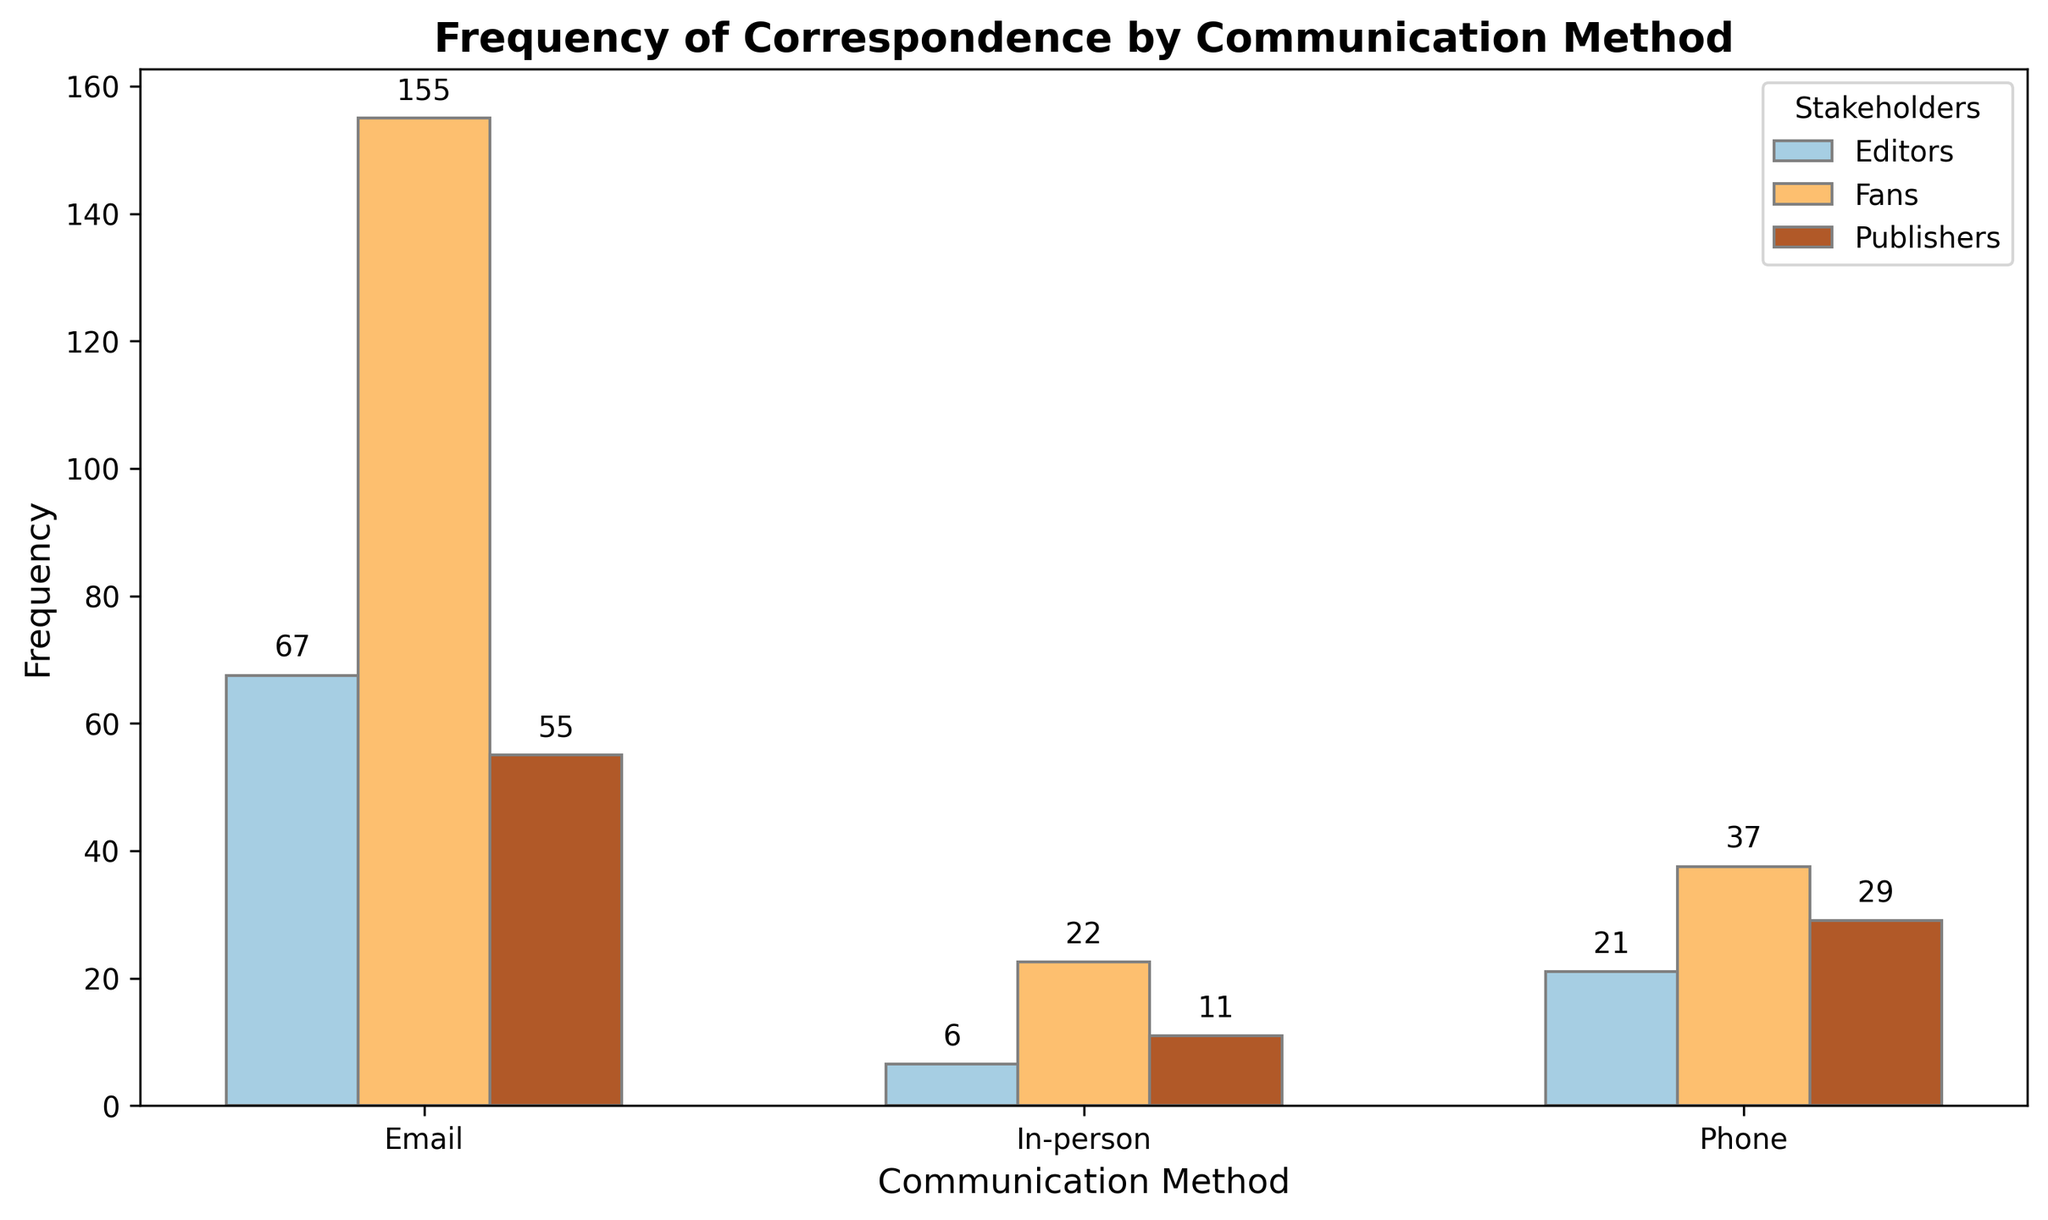What's the most common communication method with Fans? The highest bar for Fans corresponds to the "Email" method, which is taller than the bars for "Phone" and "In-person". This indicates that Fans communicate most frequently via Email.
Answer: Email How much more frequent is Email communication than Phone communication for Editors? For Editors, the frequency of Email communication is (70 + 65) / 2 = 67.5 and for Phone communication is (20 + 22) / 2 = 21. The difference is 67.5 - 21 = 46.5.
Answer: 46.5 Which stakeholder has the lowest frequency of In-person communication? By visually comparing the bars for In-person communication, Editors have the shortest bar, indicating the lowest frequency. The average frequency of In-person communication for Editors is (5 + 8) / 2 = 6.5.
Answer: Editors What's the total frequency of correspondence via Phone across all stakeholders? Summing up the average frequencies for Phone correspondence: Publishers, (30 + 28) / 2 = 29; Editors, (20 + 22) / 2 = 21; Fans, (40 + 35) / 2 = 37.5. The total is 29 + 21 + 37.5 = 87.5.
Answer: 87.5 For which stakeholder is Email communication least dominant compared to other methods? We need to compare the relative heights of the bars for each stakeholder. For Editors, the Email bar is notably higher than the others, as it is for Fans. For Publishers, the difference between Email and Phone is smallest, suggesting Email is least dominant.
Answer: Publishers Comparing Fans and Publishers, which stakeholder uses Phone communication more frequently on average? The average frequency of Phone communication for Fans is (40 + 35) / 2 = 37.5, and for Publishers, it's (30 + 28) / 2 = 29. Thus, Fans use Phone communication more frequently on average.
Answer: Fans What's the average frequency of in-person communication across all stakeholders? Calculating the average for each: Publishers, (10 + 12) / 2 = 11; Editors, (5 + 8) / 2 = 6.5; Fans, (20 + 25) / 2 = 22.5. The overall average is (11 + 6.5 + 22.5) / 3 = 13.33.
Answer: 13.33 